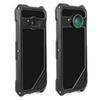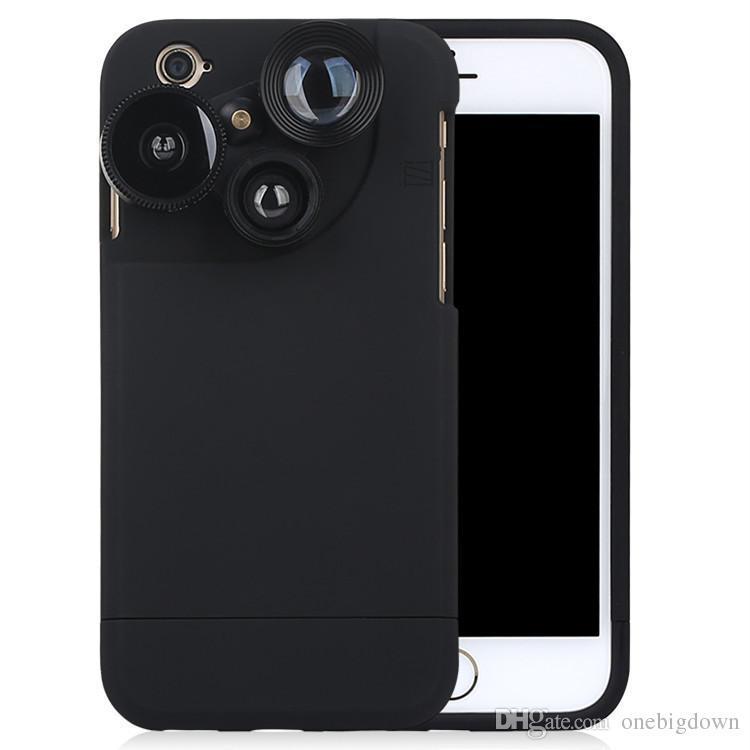The first image is the image on the left, the second image is the image on the right. Examine the images to the left and right. Is the description "Each image contains exactly two phones, and the phones depicted are displayed upright but not overlapping." accurate? Answer yes or no. No. 